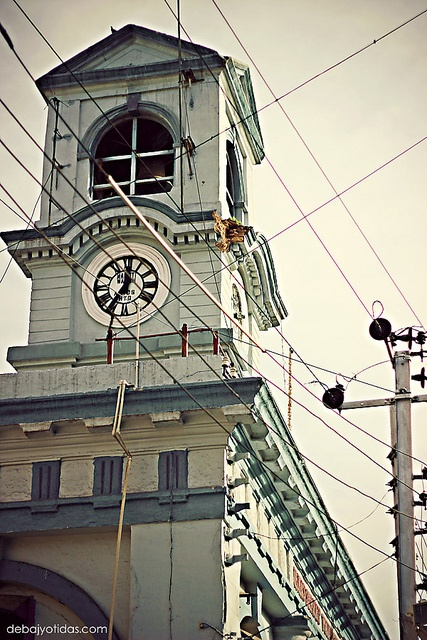Describe the objects in this image and their specific colors. I can see clock in gray, black, beige, and darkgray tones and clock in gray, beige, and black tones in this image. 